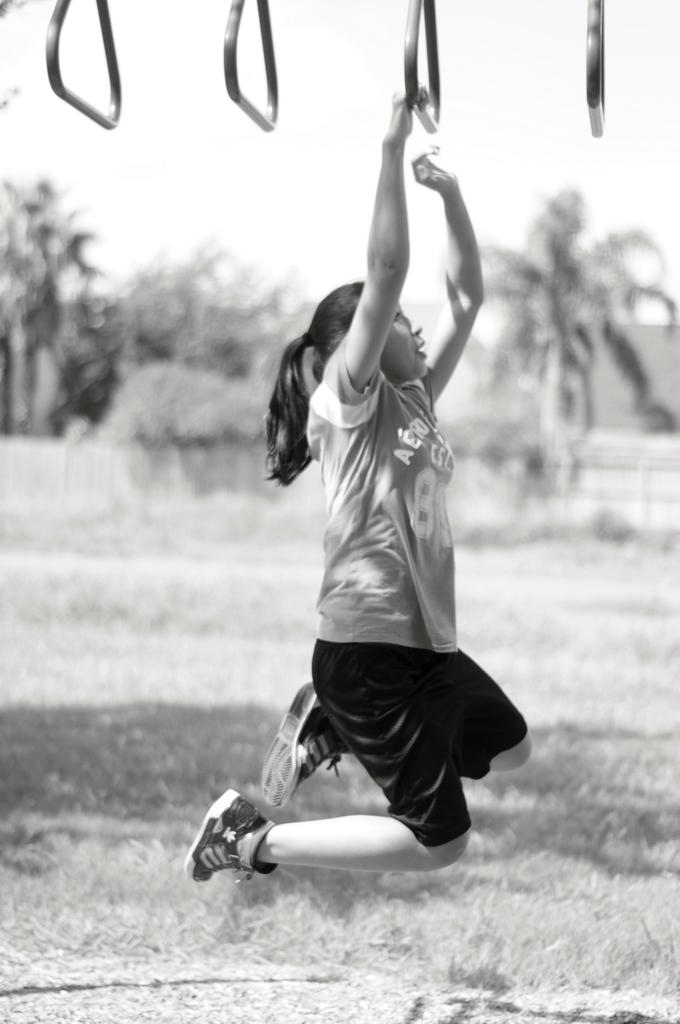What is the main subject of the image? There is a girl in the air in the image. What is the girl doing in the image? The girl is doing something (possibly performing an action or activity). What type of terrain is visible at the bottom of the image? There is grass at the bottom of the image. What can be seen in the background of the image? There are trees and buildings in the background of the image. Can you tell me how many friends the girl is helping in the image? There is no indication in the image that the girl is helping any friends, as the focus is on her activity in the air. 